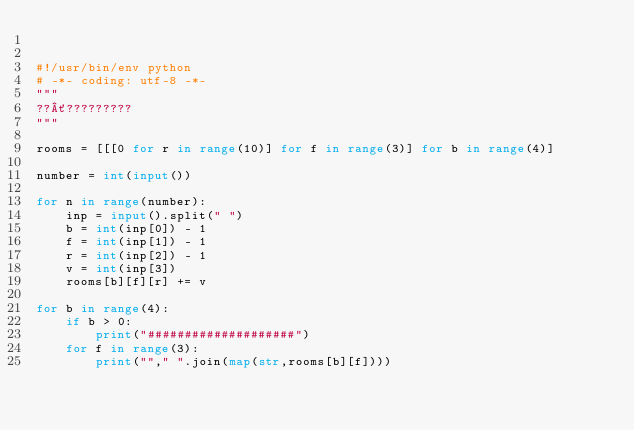Convert code to text. <code><loc_0><loc_0><loc_500><loc_500><_Python_>

#!/usr/bin/env python
# -*- coding: utf-8 -*-
"""
??´?????????
"""

rooms = [[[0 for r in range(10)] for f in range(3)] for b in range(4)]

number = int(input())

for n in range(number):
    inp = input().split(" ")
    b = int(inp[0]) - 1
    f = int(inp[1]) - 1
    r = int(inp[2]) - 1
    v = int(inp[3])
    rooms[b][f][r] += v

for b in range(4):
    if b > 0:
        print("####################")
    for f in range(3):
        print(""," ".join(map(str,rooms[b][f])))</code> 